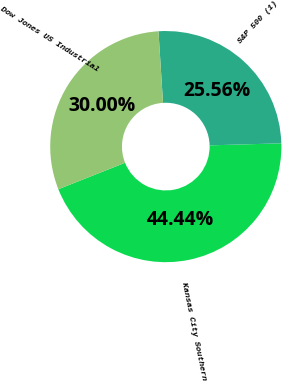Convert chart to OTSL. <chart><loc_0><loc_0><loc_500><loc_500><pie_chart><fcel>Kansas City Southern<fcel>S&P 500 (1)<fcel>Dow Jones US Industrial<nl><fcel>44.44%<fcel>25.56%<fcel>30.0%<nl></chart> 